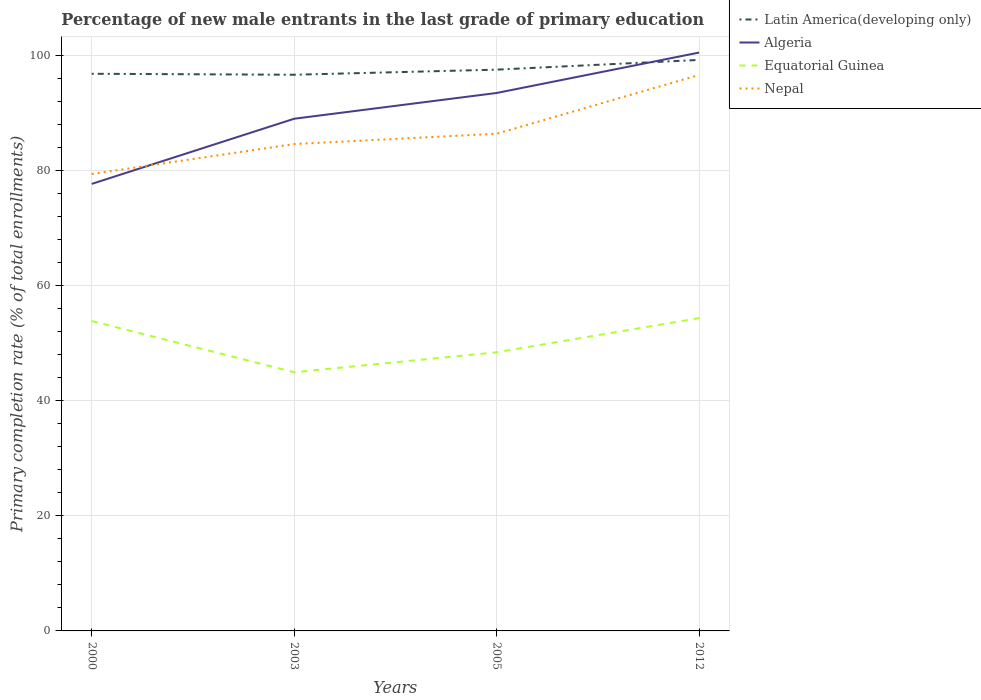Is the number of lines equal to the number of legend labels?
Offer a terse response. Yes. Across all years, what is the maximum percentage of new male entrants in Latin America(developing only)?
Offer a very short reply. 96.61. In which year was the percentage of new male entrants in Equatorial Guinea maximum?
Make the answer very short. 2003. What is the total percentage of new male entrants in Nepal in the graph?
Your answer should be compact. -5.19. What is the difference between the highest and the second highest percentage of new male entrants in Nepal?
Offer a terse response. 17.19. What is the difference between the highest and the lowest percentage of new male entrants in Latin America(developing only)?
Offer a terse response. 1. How many lines are there?
Offer a terse response. 4. How many years are there in the graph?
Keep it short and to the point. 4. Are the values on the major ticks of Y-axis written in scientific E-notation?
Your answer should be compact. No. How many legend labels are there?
Your answer should be very brief. 4. How are the legend labels stacked?
Offer a very short reply. Vertical. What is the title of the graph?
Keep it short and to the point. Percentage of new male entrants in the last grade of primary education. Does "Madagascar" appear as one of the legend labels in the graph?
Your answer should be compact. No. What is the label or title of the Y-axis?
Offer a terse response. Primary completion rate (% of total enrollments). What is the Primary completion rate (% of total enrollments) in Latin America(developing only) in 2000?
Your answer should be very brief. 96.78. What is the Primary completion rate (% of total enrollments) in Algeria in 2000?
Ensure brevity in your answer.  77.65. What is the Primary completion rate (% of total enrollments) of Equatorial Guinea in 2000?
Make the answer very short. 53.83. What is the Primary completion rate (% of total enrollments) of Nepal in 2000?
Provide a succinct answer. 79.37. What is the Primary completion rate (% of total enrollments) in Latin America(developing only) in 2003?
Provide a short and direct response. 96.61. What is the Primary completion rate (% of total enrollments) of Algeria in 2003?
Give a very brief answer. 88.97. What is the Primary completion rate (% of total enrollments) in Equatorial Guinea in 2003?
Make the answer very short. 44.93. What is the Primary completion rate (% of total enrollments) in Nepal in 2003?
Your answer should be compact. 84.57. What is the Primary completion rate (% of total enrollments) in Latin America(developing only) in 2005?
Your response must be concise. 97.49. What is the Primary completion rate (% of total enrollments) in Algeria in 2005?
Give a very brief answer. 93.44. What is the Primary completion rate (% of total enrollments) in Equatorial Guinea in 2005?
Provide a succinct answer. 48.4. What is the Primary completion rate (% of total enrollments) of Nepal in 2005?
Ensure brevity in your answer.  86.36. What is the Primary completion rate (% of total enrollments) in Latin America(developing only) in 2012?
Ensure brevity in your answer.  99.18. What is the Primary completion rate (% of total enrollments) in Algeria in 2012?
Provide a succinct answer. 100.46. What is the Primary completion rate (% of total enrollments) of Equatorial Guinea in 2012?
Your response must be concise. 54.34. What is the Primary completion rate (% of total enrollments) in Nepal in 2012?
Keep it short and to the point. 96.56. Across all years, what is the maximum Primary completion rate (% of total enrollments) of Latin America(developing only)?
Offer a very short reply. 99.18. Across all years, what is the maximum Primary completion rate (% of total enrollments) of Algeria?
Your answer should be very brief. 100.46. Across all years, what is the maximum Primary completion rate (% of total enrollments) of Equatorial Guinea?
Ensure brevity in your answer.  54.34. Across all years, what is the maximum Primary completion rate (% of total enrollments) in Nepal?
Keep it short and to the point. 96.56. Across all years, what is the minimum Primary completion rate (% of total enrollments) in Latin America(developing only)?
Your response must be concise. 96.61. Across all years, what is the minimum Primary completion rate (% of total enrollments) of Algeria?
Ensure brevity in your answer.  77.65. Across all years, what is the minimum Primary completion rate (% of total enrollments) of Equatorial Guinea?
Make the answer very short. 44.93. Across all years, what is the minimum Primary completion rate (% of total enrollments) in Nepal?
Ensure brevity in your answer.  79.37. What is the total Primary completion rate (% of total enrollments) in Latin America(developing only) in the graph?
Provide a succinct answer. 390.06. What is the total Primary completion rate (% of total enrollments) of Algeria in the graph?
Your answer should be compact. 360.52. What is the total Primary completion rate (% of total enrollments) in Equatorial Guinea in the graph?
Your response must be concise. 201.49. What is the total Primary completion rate (% of total enrollments) in Nepal in the graph?
Make the answer very short. 346.87. What is the difference between the Primary completion rate (% of total enrollments) of Latin America(developing only) in 2000 and that in 2003?
Offer a terse response. 0.17. What is the difference between the Primary completion rate (% of total enrollments) of Algeria in 2000 and that in 2003?
Your answer should be compact. -11.32. What is the difference between the Primary completion rate (% of total enrollments) in Equatorial Guinea in 2000 and that in 2003?
Your response must be concise. 8.89. What is the difference between the Primary completion rate (% of total enrollments) in Nepal in 2000 and that in 2003?
Your answer should be compact. -5.19. What is the difference between the Primary completion rate (% of total enrollments) of Latin America(developing only) in 2000 and that in 2005?
Keep it short and to the point. -0.72. What is the difference between the Primary completion rate (% of total enrollments) in Algeria in 2000 and that in 2005?
Offer a terse response. -15.79. What is the difference between the Primary completion rate (% of total enrollments) of Equatorial Guinea in 2000 and that in 2005?
Ensure brevity in your answer.  5.43. What is the difference between the Primary completion rate (% of total enrollments) of Nepal in 2000 and that in 2005?
Your answer should be compact. -6.99. What is the difference between the Primary completion rate (% of total enrollments) of Latin America(developing only) in 2000 and that in 2012?
Offer a terse response. -2.41. What is the difference between the Primary completion rate (% of total enrollments) in Algeria in 2000 and that in 2012?
Your response must be concise. -22.81. What is the difference between the Primary completion rate (% of total enrollments) of Equatorial Guinea in 2000 and that in 2012?
Ensure brevity in your answer.  -0.51. What is the difference between the Primary completion rate (% of total enrollments) of Nepal in 2000 and that in 2012?
Keep it short and to the point. -17.19. What is the difference between the Primary completion rate (% of total enrollments) in Latin America(developing only) in 2003 and that in 2005?
Your response must be concise. -0.89. What is the difference between the Primary completion rate (% of total enrollments) of Algeria in 2003 and that in 2005?
Give a very brief answer. -4.47. What is the difference between the Primary completion rate (% of total enrollments) in Equatorial Guinea in 2003 and that in 2005?
Your response must be concise. -3.47. What is the difference between the Primary completion rate (% of total enrollments) in Nepal in 2003 and that in 2005?
Your answer should be very brief. -1.8. What is the difference between the Primary completion rate (% of total enrollments) in Latin America(developing only) in 2003 and that in 2012?
Provide a short and direct response. -2.57. What is the difference between the Primary completion rate (% of total enrollments) of Algeria in 2003 and that in 2012?
Offer a very short reply. -11.49. What is the difference between the Primary completion rate (% of total enrollments) of Equatorial Guinea in 2003 and that in 2012?
Offer a terse response. -9.4. What is the difference between the Primary completion rate (% of total enrollments) of Nepal in 2003 and that in 2012?
Provide a short and direct response. -12. What is the difference between the Primary completion rate (% of total enrollments) of Latin America(developing only) in 2005 and that in 2012?
Make the answer very short. -1.69. What is the difference between the Primary completion rate (% of total enrollments) of Algeria in 2005 and that in 2012?
Provide a short and direct response. -7.02. What is the difference between the Primary completion rate (% of total enrollments) of Equatorial Guinea in 2005 and that in 2012?
Your response must be concise. -5.94. What is the difference between the Primary completion rate (% of total enrollments) of Nepal in 2005 and that in 2012?
Give a very brief answer. -10.2. What is the difference between the Primary completion rate (% of total enrollments) of Latin America(developing only) in 2000 and the Primary completion rate (% of total enrollments) of Algeria in 2003?
Provide a succinct answer. 7.81. What is the difference between the Primary completion rate (% of total enrollments) in Latin America(developing only) in 2000 and the Primary completion rate (% of total enrollments) in Equatorial Guinea in 2003?
Offer a terse response. 51.84. What is the difference between the Primary completion rate (% of total enrollments) in Latin America(developing only) in 2000 and the Primary completion rate (% of total enrollments) in Nepal in 2003?
Provide a short and direct response. 12.21. What is the difference between the Primary completion rate (% of total enrollments) of Algeria in 2000 and the Primary completion rate (% of total enrollments) of Equatorial Guinea in 2003?
Ensure brevity in your answer.  32.71. What is the difference between the Primary completion rate (% of total enrollments) of Algeria in 2000 and the Primary completion rate (% of total enrollments) of Nepal in 2003?
Make the answer very short. -6.92. What is the difference between the Primary completion rate (% of total enrollments) of Equatorial Guinea in 2000 and the Primary completion rate (% of total enrollments) of Nepal in 2003?
Your answer should be very brief. -30.74. What is the difference between the Primary completion rate (% of total enrollments) in Latin America(developing only) in 2000 and the Primary completion rate (% of total enrollments) in Algeria in 2005?
Provide a succinct answer. 3.33. What is the difference between the Primary completion rate (% of total enrollments) in Latin America(developing only) in 2000 and the Primary completion rate (% of total enrollments) in Equatorial Guinea in 2005?
Give a very brief answer. 48.38. What is the difference between the Primary completion rate (% of total enrollments) in Latin America(developing only) in 2000 and the Primary completion rate (% of total enrollments) in Nepal in 2005?
Your answer should be very brief. 10.41. What is the difference between the Primary completion rate (% of total enrollments) of Algeria in 2000 and the Primary completion rate (% of total enrollments) of Equatorial Guinea in 2005?
Ensure brevity in your answer.  29.25. What is the difference between the Primary completion rate (% of total enrollments) of Algeria in 2000 and the Primary completion rate (% of total enrollments) of Nepal in 2005?
Offer a terse response. -8.72. What is the difference between the Primary completion rate (% of total enrollments) of Equatorial Guinea in 2000 and the Primary completion rate (% of total enrollments) of Nepal in 2005?
Offer a very short reply. -32.54. What is the difference between the Primary completion rate (% of total enrollments) of Latin America(developing only) in 2000 and the Primary completion rate (% of total enrollments) of Algeria in 2012?
Offer a very short reply. -3.69. What is the difference between the Primary completion rate (% of total enrollments) of Latin America(developing only) in 2000 and the Primary completion rate (% of total enrollments) of Equatorial Guinea in 2012?
Your answer should be compact. 42.44. What is the difference between the Primary completion rate (% of total enrollments) of Latin America(developing only) in 2000 and the Primary completion rate (% of total enrollments) of Nepal in 2012?
Your response must be concise. 0.21. What is the difference between the Primary completion rate (% of total enrollments) in Algeria in 2000 and the Primary completion rate (% of total enrollments) in Equatorial Guinea in 2012?
Your answer should be very brief. 23.31. What is the difference between the Primary completion rate (% of total enrollments) in Algeria in 2000 and the Primary completion rate (% of total enrollments) in Nepal in 2012?
Provide a succinct answer. -18.92. What is the difference between the Primary completion rate (% of total enrollments) in Equatorial Guinea in 2000 and the Primary completion rate (% of total enrollments) in Nepal in 2012?
Provide a succinct answer. -42.74. What is the difference between the Primary completion rate (% of total enrollments) in Latin America(developing only) in 2003 and the Primary completion rate (% of total enrollments) in Algeria in 2005?
Your answer should be compact. 3.17. What is the difference between the Primary completion rate (% of total enrollments) in Latin America(developing only) in 2003 and the Primary completion rate (% of total enrollments) in Equatorial Guinea in 2005?
Make the answer very short. 48.21. What is the difference between the Primary completion rate (% of total enrollments) in Latin America(developing only) in 2003 and the Primary completion rate (% of total enrollments) in Nepal in 2005?
Your answer should be very brief. 10.24. What is the difference between the Primary completion rate (% of total enrollments) in Algeria in 2003 and the Primary completion rate (% of total enrollments) in Equatorial Guinea in 2005?
Offer a terse response. 40.57. What is the difference between the Primary completion rate (% of total enrollments) of Algeria in 2003 and the Primary completion rate (% of total enrollments) of Nepal in 2005?
Your response must be concise. 2.6. What is the difference between the Primary completion rate (% of total enrollments) in Equatorial Guinea in 2003 and the Primary completion rate (% of total enrollments) in Nepal in 2005?
Your answer should be compact. -41.43. What is the difference between the Primary completion rate (% of total enrollments) of Latin America(developing only) in 2003 and the Primary completion rate (% of total enrollments) of Algeria in 2012?
Make the answer very short. -3.85. What is the difference between the Primary completion rate (% of total enrollments) of Latin America(developing only) in 2003 and the Primary completion rate (% of total enrollments) of Equatorial Guinea in 2012?
Keep it short and to the point. 42.27. What is the difference between the Primary completion rate (% of total enrollments) in Latin America(developing only) in 2003 and the Primary completion rate (% of total enrollments) in Nepal in 2012?
Ensure brevity in your answer.  0.04. What is the difference between the Primary completion rate (% of total enrollments) of Algeria in 2003 and the Primary completion rate (% of total enrollments) of Equatorial Guinea in 2012?
Offer a very short reply. 34.63. What is the difference between the Primary completion rate (% of total enrollments) of Algeria in 2003 and the Primary completion rate (% of total enrollments) of Nepal in 2012?
Provide a short and direct response. -7.6. What is the difference between the Primary completion rate (% of total enrollments) of Equatorial Guinea in 2003 and the Primary completion rate (% of total enrollments) of Nepal in 2012?
Your answer should be very brief. -51.63. What is the difference between the Primary completion rate (% of total enrollments) of Latin America(developing only) in 2005 and the Primary completion rate (% of total enrollments) of Algeria in 2012?
Offer a very short reply. -2.97. What is the difference between the Primary completion rate (% of total enrollments) of Latin America(developing only) in 2005 and the Primary completion rate (% of total enrollments) of Equatorial Guinea in 2012?
Your answer should be compact. 43.16. What is the difference between the Primary completion rate (% of total enrollments) of Latin America(developing only) in 2005 and the Primary completion rate (% of total enrollments) of Nepal in 2012?
Make the answer very short. 0.93. What is the difference between the Primary completion rate (% of total enrollments) of Algeria in 2005 and the Primary completion rate (% of total enrollments) of Equatorial Guinea in 2012?
Your answer should be compact. 39.11. What is the difference between the Primary completion rate (% of total enrollments) of Algeria in 2005 and the Primary completion rate (% of total enrollments) of Nepal in 2012?
Provide a short and direct response. -3.12. What is the difference between the Primary completion rate (% of total enrollments) in Equatorial Guinea in 2005 and the Primary completion rate (% of total enrollments) in Nepal in 2012?
Offer a very short reply. -48.16. What is the average Primary completion rate (% of total enrollments) of Latin America(developing only) per year?
Offer a very short reply. 97.51. What is the average Primary completion rate (% of total enrollments) in Algeria per year?
Your answer should be compact. 90.13. What is the average Primary completion rate (% of total enrollments) of Equatorial Guinea per year?
Provide a short and direct response. 50.37. What is the average Primary completion rate (% of total enrollments) in Nepal per year?
Make the answer very short. 86.72. In the year 2000, what is the difference between the Primary completion rate (% of total enrollments) in Latin America(developing only) and Primary completion rate (% of total enrollments) in Algeria?
Offer a terse response. 19.13. In the year 2000, what is the difference between the Primary completion rate (% of total enrollments) of Latin America(developing only) and Primary completion rate (% of total enrollments) of Equatorial Guinea?
Offer a very short reply. 42.95. In the year 2000, what is the difference between the Primary completion rate (% of total enrollments) in Latin America(developing only) and Primary completion rate (% of total enrollments) in Nepal?
Give a very brief answer. 17.4. In the year 2000, what is the difference between the Primary completion rate (% of total enrollments) in Algeria and Primary completion rate (% of total enrollments) in Equatorial Guinea?
Provide a succinct answer. 23.82. In the year 2000, what is the difference between the Primary completion rate (% of total enrollments) in Algeria and Primary completion rate (% of total enrollments) in Nepal?
Provide a short and direct response. -1.73. In the year 2000, what is the difference between the Primary completion rate (% of total enrollments) of Equatorial Guinea and Primary completion rate (% of total enrollments) of Nepal?
Your answer should be compact. -25.55. In the year 2003, what is the difference between the Primary completion rate (% of total enrollments) in Latin America(developing only) and Primary completion rate (% of total enrollments) in Algeria?
Offer a terse response. 7.64. In the year 2003, what is the difference between the Primary completion rate (% of total enrollments) of Latin America(developing only) and Primary completion rate (% of total enrollments) of Equatorial Guinea?
Provide a short and direct response. 51.67. In the year 2003, what is the difference between the Primary completion rate (% of total enrollments) of Latin America(developing only) and Primary completion rate (% of total enrollments) of Nepal?
Give a very brief answer. 12.04. In the year 2003, what is the difference between the Primary completion rate (% of total enrollments) of Algeria and Primary completion rate (% of total enrollments) of Equatorial Guinea?
Your answer should be compact. 44.03. In the year 2003, what is the difference between the Primary completion rate (% of total enrollments) in Algeria and Primary completion rate (% of total enrollments) in Nepal?
Make the answer very short. 4.4. In the year 2003, what is the difference between the Primary completion rate (% of total enrollments) of Equatorial Guinea and Primary completion rate (% of total enrollments) of Nepal?
Provide a short and direct response. -39.63. In the year 2005, what is the difference between the Primary completion rate (% of total enrollments) in Latin America(developing only) and Primary completion rate (% of total enrollments) in Algeria?
Make the answer very short. 4.05. In the year 2005, what is the difference between the Primary completion rate (% of total enrollments) in Latin America(developing only) and Primary completion rate (% of total enrollments) in Equatorial Guinea?
Your answer should be very brief. 49.09. In the year 2005, what is the difference between the Primary completion rate (% of total enrollments) of Latin America(developing only) and Primary completion rate (% of total enrollments) of Nepal?
Ensure brevity in your answer.  11.13. In the year 2005, what is the difference between the Primary completion rate (% of total enrollments) of Algeria and Primary completion rate (% of total enrollments) of Equatorial Guinea?
Give a very brief answer. 45.04. In the year 2005, what is the difference between the Primary completion rate (% of total enrollments) in Algeria and Primary completion rate (% of total enrollments) in Nepal?
Offer a very short reply. 7.08. In the year 2005, what is the difference between the Primary completion rate (% of total enrollments) in Equatorial Guinea and Primary completion rate (% of total enrollments) in Nepal?
Ensure brevity in your answer.  -37.96. In the year 2012, what is the difference between the Primary completion rate (% of total enrollments) in Latin America(developing only) and Primary completion rate (% of total enrollments) in Algeria?
Keep it short and to the point. -1.28. In the year 2012, what is the difference between the Primary completion rate (% of total enrollments) in Latin America(developing only) and Primary completion rate (% of total enrollments) in Equatorial Guinea?
Keep it short and to the point. 44.85. In the year 2012, what is the difference between the Primary completion rate (% of total enrollments) of Latin America(developing only) and Primary completion rate (% of total enrollments) of Nepal?
Offer a very short reply. 2.62. In the year 2012, what is the difference between the Primary completion rate (% of total enrollments) of Algeria and Primary completion rate (% of total enrollments) of Equatorial Guinea?
Ensure brevity in your answer.  46.13. In the year 2012, what is the difference between the Primary completion rate (% of total enrollments) of Algeria and Primary completion rate (% of total enrollments) of Nepal?
Your response must be concise. 3.9. In the year 2012, what is the difference between the Primary completion rate (% of total enrollments) of Equatorial Guinea and Primary completion rate (% of total enrollments) of Nepal?
Your response must be concise. -42.23. What is the ratio of the Primary completion rate (% of total enrollments) of Algeria in 2000 to that in 2003?
Make the answer very short. 0.87. What is the ratio of the Primary completion rate (% of total enrollments) of Equatorial Guinea in 2000 to that in 2003?
Offer a terse response. 1.2. What is the ratio of the Primary completion rate (% of total enrollments) in Nepal in 2000 to that in 2003?
Ensure brevity in your answer.  0.94. What is the ratio of the Primary completion rate (% of total enrollments) in Algeria in 2000 to that in 2005?
Your answer should be very brief. 0.83. What is the ratio of the Primary completion rate (% of total enrollments) in Equatorial Guinea in 2000 to that in 2005?
Your answer should be very brief. 1.11. What is the ratio of the Primary completion rate (% of total enrollments) of Nepal in 2000 to that in 2005?
Make the answer very short. 0.92. What is the ratio of the Primary completion rate (% of total enrollments) in Latin America(developing only) in 2000 to that in 2012?
Give a very brief answer. 0.98. What is the ratio of the Primary completion rate (% of total enrollments) of Algeria in 2000 to that in 2012?
Give a very brief answer. 0.77. What is the ratio of the Primary completion rate (% of total enrollments) of Equatorial Guinea in 2000 to that in 2012?
Your answer should be very brief. 0.99. What is the ratio of the Primary completion rate (% of total enrollments) of Nepal in 2000 to that in 2012?
Make the answer very short. 0.82. What is the ratio of the Primary completion rate (% of total enrollments) of Latin America(developing only) in 2003 to that in 2005?
Your answer should be compact. 0.99. What is the ratio of the Primary completion rate (% of total enrollments) of Algeria in 2003 to that in 2005?
Ensure brevity in your answer.  0.95. What is the ratio of the Primary completion rate (% of total enrollments) of Equatorial Guinea in 2003 to that in 2005?
Offer a very short reply. 0.93. What is the ratio of the Primary completion rate (% of total enrollments) in Nepal in 2003 to that in 2005?
Your answer should be compact. 0.98. What is the ratio of the Primary completion rate (% of total enrollments) of Algeria in 2003 to that in 2012?
Ensure brevity in your answer.  0.89. What is the ratio of the Primary completion rate (% of total enrollments) of Equatorial Guinea in 2003 to that in 2012?
Ensure brevity in your answer.  0.83. What is the ratio of the Primary completion rate (% of total enrollments) of Nepal in 2003 to that in 2012?
Your answer should be compact. 0.88. What is the ratio of the Primary completion rate (% of total enrollments) in Algeria in 2005 to that in 2012?
Your answer should be compact. 0.93. What is the ratio of the Primary completion rate (% of total enrollments) of Equatorial Guinea in 2005 to that in 2012?
Your answer should be very brief. 0.89. What is the ratio of the Primary completion rate (% of total enrollments) in Nepal in 2005 to that in 2012?
Your response must be concise. 0.89. What is the difference between the highest and the second highest Primary completion rate (% of total enrollments) of Latin America(developing only)?
Give a very brief answer. 1.69. What is the difference between the highest and the second highest Primary completion rate (% of total enrollments) in Algeria?
Give a very brief answer. 7.02. What is the difference between the highest and the second highest Primary completion rate (% of total enrollments) of Equatorial Guinea?
Give a very brief answer. 0.51. What is the difference between the highest and the second highest Primary completion rate (% of total enrollments) in Nepal?
Your response must be concise. 10.2. What is the difference between the highest and the lowest Primary completion rate (% of total enrollments) of Latin America(developing only)?
Make the answer very short. 2.57. What is the difference between the highest and the lowest Primary completion rate (% of total enrollments) in Algeria?
Offer a very short reply. 22.81. What is the difference between the highest and the lowest Primary completion rate (% of total enrollments) of Equatorial Guinea?
Offer a very short reply. 9.4. What is the difference between the highest and the lowest Primary completion rate (% of total enrollments) in Nepal?
Provide a short and direct response. 17.19. 